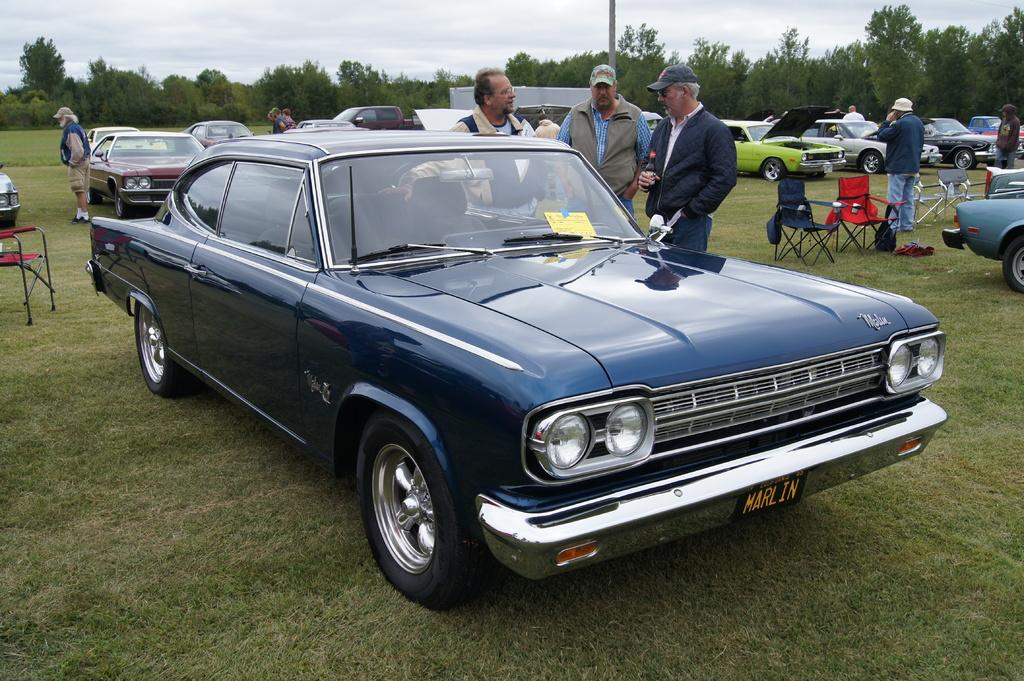<image>
Render a clear and concise summary of the photo. Men gather around a vintage blue car with a license plate that says,"Marlin". 